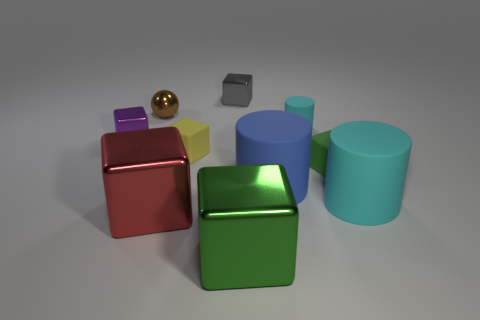Does the rubber thing behind the small yellow thing have the same color as the shiny ball?
Provide a succinct answer. No. What number of other objects are the same size as the green shiny thing?
Your answer should be very brief. 3. Does the large red cube have the same material as the tiny brown ball?
Keep it short and to the point. Yes. There is a small rubber block that is on the left side of the shiny thing that is on the right side of the gray metallic block; what color is it?
Ensure brevity in your answer.  Yellow. What size is the green matte thing that is the same shape as the big green shiny thing?
Provide a short and direct response. Small. Does the ball have the same color as the tiny cylinder?
Provide a short and direct response. No. How many cylinders are on the left side of the cyan thing that is in front of the block that is right of the big green shiny block?
Your response must be concise. 2. Are there more tiny red rubber things than purple metallic cubes?
Offer a very short reply. No. How many big blue cubes are there?
Offer a terse response. 0. What shape is the brown shiny object that is behind the green cube that is right of the big metallic block in front of the red block?
Give a very brief answer. Sphere. 